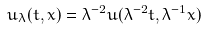<formula> <loc_0><loc_0><loc_500><loc_500>u _ { \lambda } ( t , x ) = \lambda ^ { - 2 } u ( \lambda ^ { - 2 } t , \lambda ^ { - 1 } x )</formula> 